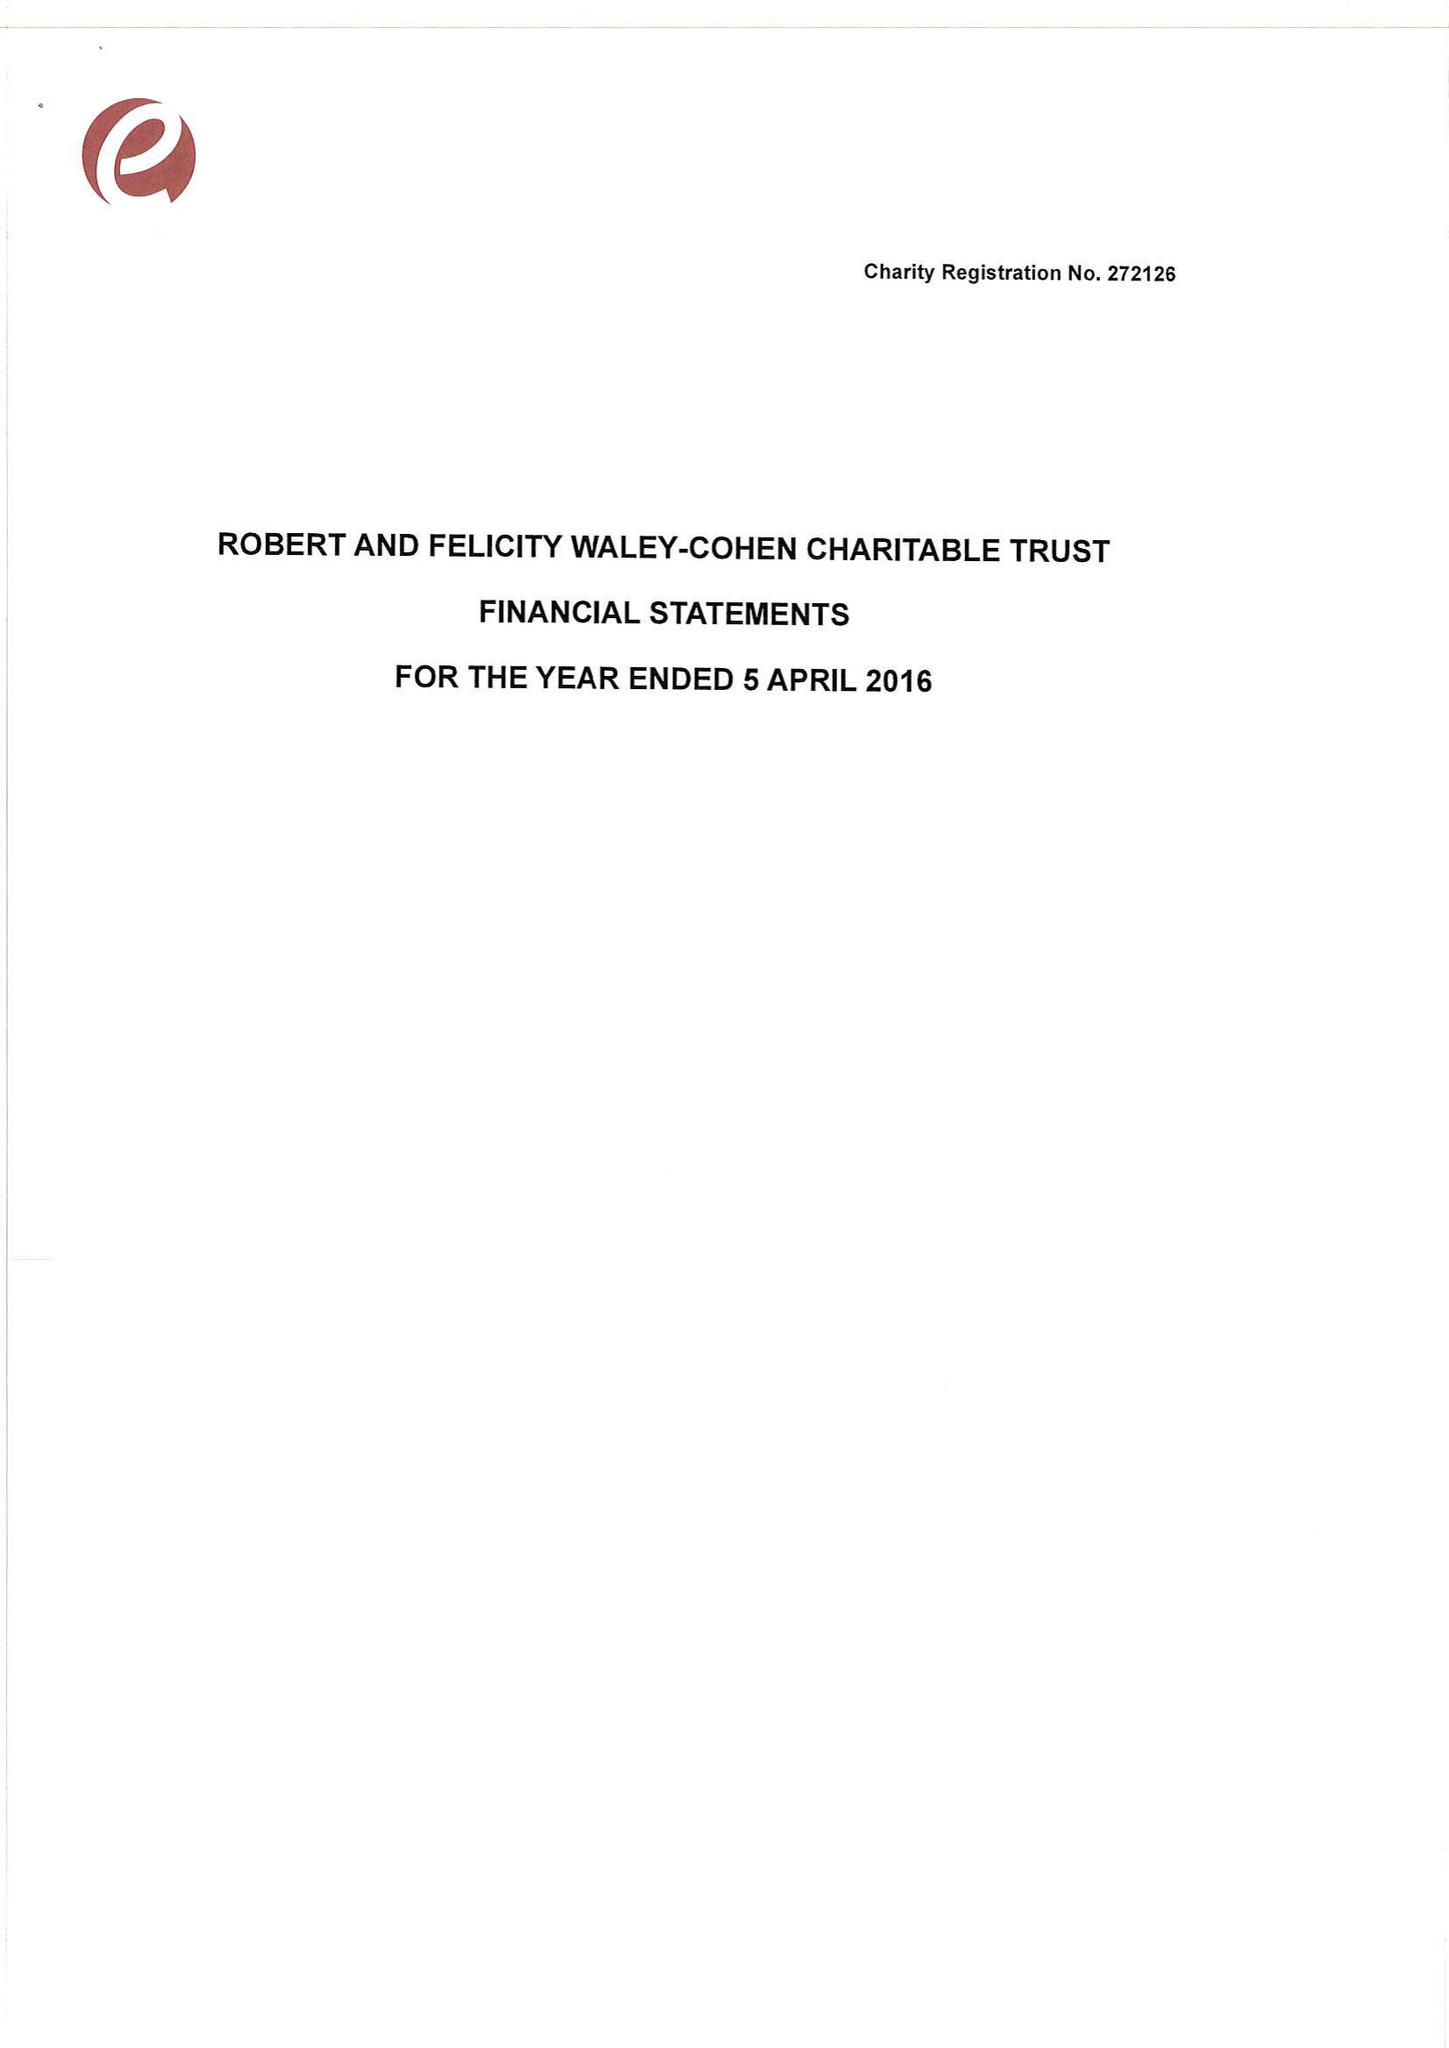What is the value for the address__post_town?
Answer the question using a single word or phrase. LONDON 